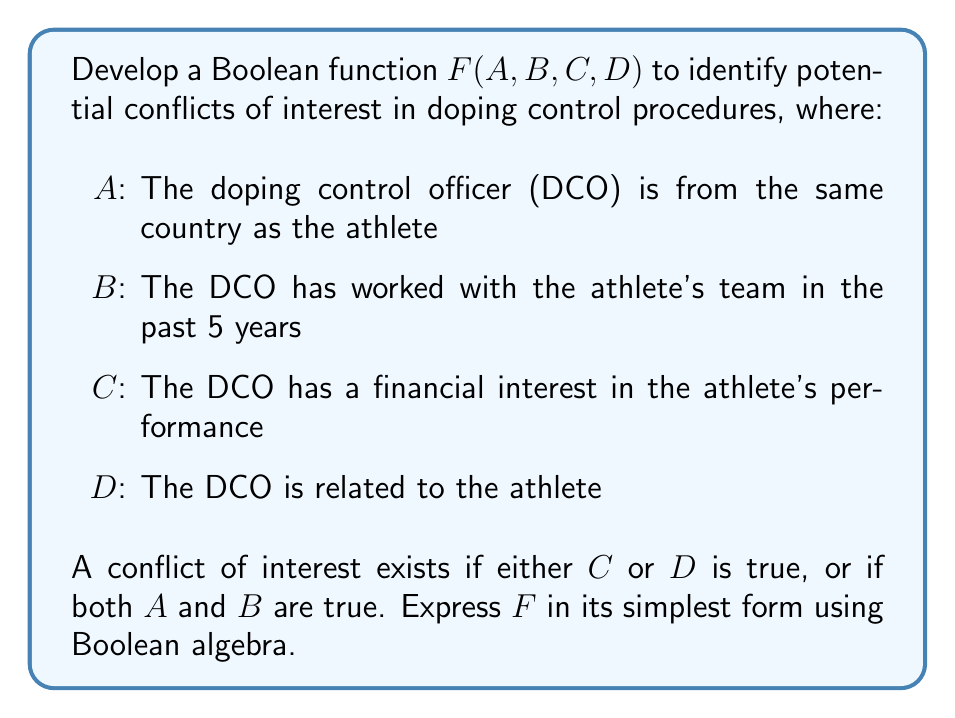Solve this math problem. To develop the Boolean function $F(A, B, C, D)$, we follow these steps:

1. Translate the given conditions into Boolean expressions:
   - $C$ or $D$ is true: $C + D$
   - Both $A$ and $B$ are true: $A \cdot B$

2. Combine these conditions using the OR operation:
   $F(A, B, C, D) = (C + D) + (A \cdot B)$

3. Apply the distributive law to simplify:
   $F(A, B, C, D) = C + D + (A \cdot B)$

This expression is already in its simplest form, as we cannot further reduce it using Boolean algebra laws.
Answer: $F(A, B, C, D) = C + D + (A \cdot B)$ 